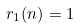<formula> <loc_0><loc_0><loc_500><loc_500>r _ { 1 } ( n ) = 1</formula> 